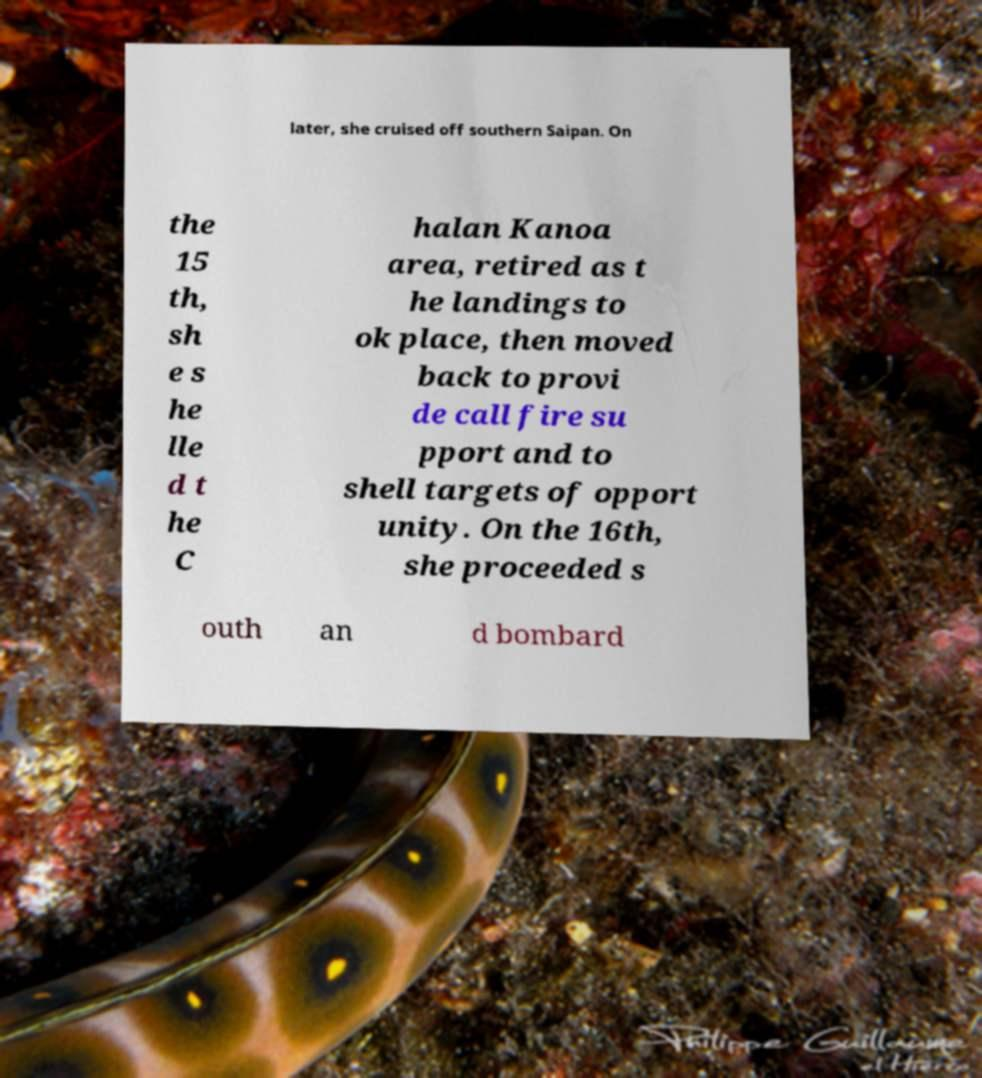I need the written content from this picture converted into text. Can you do that? later, she cruised off southern Saipan. On the 15 th, sh e s he lle d t he C halan Kanoa area, retired as t he landings to ok place, then moved back to provi de call fire su pport and to shell targets of opport unity. On the 16th, she proceeded s outh an d bombard 